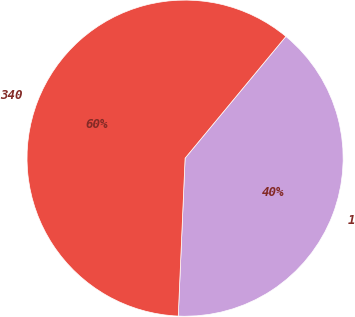Convert chart. <chart><loc_0><loc_0><loc_500><loc_500><pie_chart><fcel>1<fcel>340<nl><fcel>39.68%<fcel>60.32%<nl></chart> 